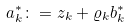Convert formula to latex. <formula><loc_0><loc_0><loc_500><loc_500>a _ { k } ^ { * } \colon = z _ { k } + \varrho _ { k } b _ { k } ^ { * }</formula> 